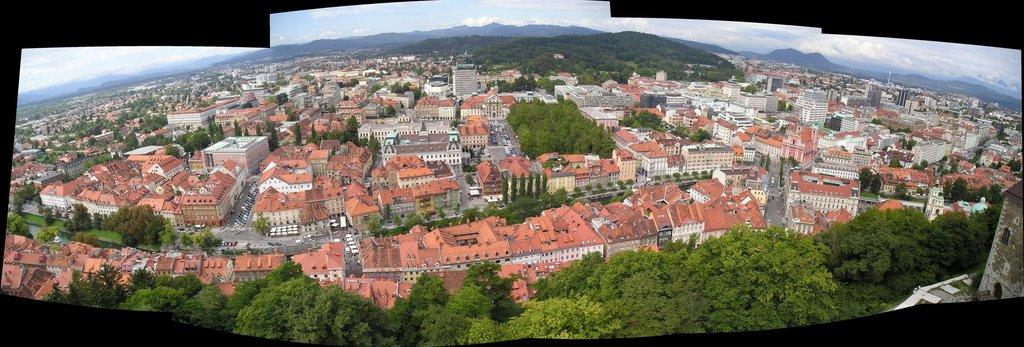What type of vegetation can be seen in the image? There are many trees in the image. What type of structures are visible in the image? There are buildings with windows in the image. What type of transportation infrastructure can be seen in the image? There are roads in the image. What type of natural landform can be seen in the background of the image? In the background of the image, there are hills. What part of the natural environment is visible in the image? The sky is visible in the image. What type of weather condition can be inferred from the image? Clouds are present in the sky, suggesting a partly cloudy day. Where is the drawer located in the image? There is no drawer present in the image. What type of station can be seen in the image? There is no station present in the image. 